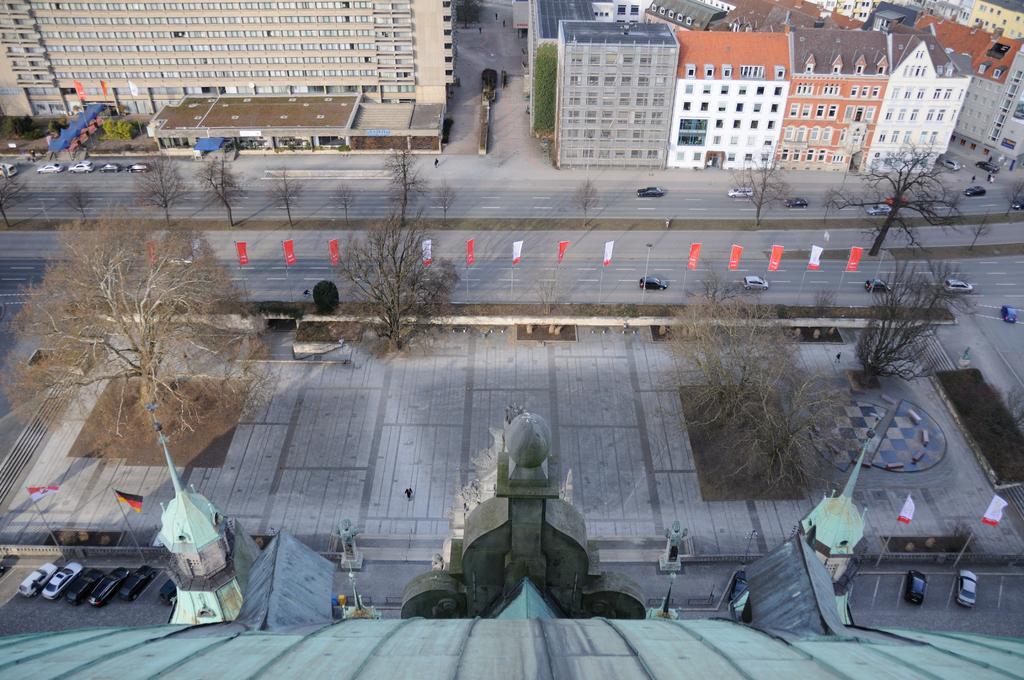Could you give a brief overview of what you see in this image? In this picture we can see trees, plants, banners and flags on poles. We can see buildings, vehicles and road. 